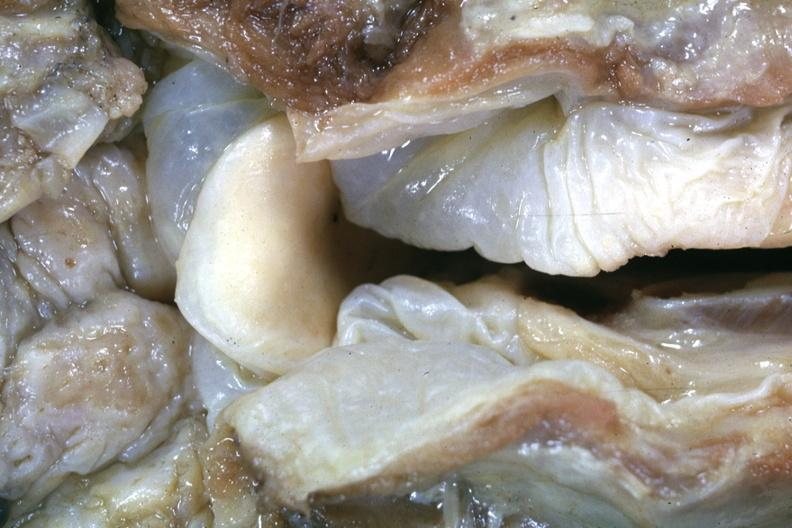what does this image show?
Answer the question using a single word or phrase. Close-up view of very edematous hypopharyngeal mucosa with opened larynx is a very good example of a lesion seldom seen at autopsy slide is a more distant view of specimen after fixation 